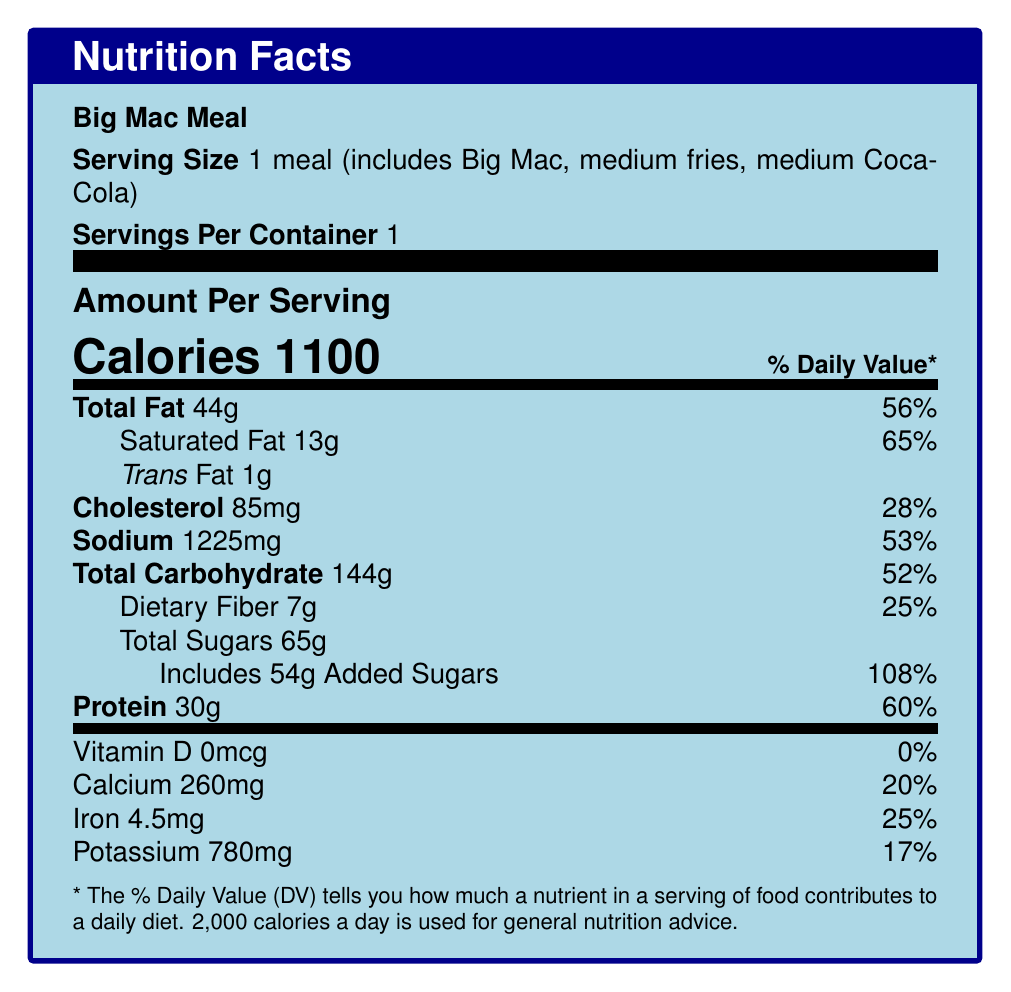what is the serving size of the Big Mac Meal? The document specifies that the serving size is 1 meal, which includes a Big Mac, medium fries, and a medium Coca-Cola.
Answer: 1 meal (includes Big Mac, medium fries, medium Coca-Cola) how many calories are in one serving of the Big Mac Meal? The document states that the meal contains 1100 calories per serving.
Answer: 1100 what is the amount of total fat in one serving? The document lists the total fat content as 44 grams per serving.
Answer: 44g how much sodium does the Big Mac Meal contain? The sodium content in one serving of the Big Mac Meal is 1225 milligrams.
Answer: 1225mg what percentage of the Daily Value for added sugars does the Big Mac Meal provide? The document indicates that the added sugars amount to 54 grams, which is 108% of the Daily Value.
Answer: 108% how much protein is in one serving of the Big Mac Meal? The meal provides 30 grams of protein per serving.
Answer: 30g what is the total carbohydrate content in one serving? A. 144g B. 100g C. 52g D. 200g The total carbohydrate content is 144 grams per serving, as stated in the document.
Answer: A. 144g what are the daily values for saturated fat and iron in the Big Mac Meal? I. 20% II. 25% III. 65% IV. 50% Saturated fat is 65% of the Daily Value, and iron is 25% of the Daily Value, as provided in the document.
Answer: III. 65% (Saturated fat), II. 25% (Iron) is there any Vitamin D in the Big Mac Meal? The document specifies that the Vitamin D content is 0 mcg, which accounts for 0% of the Daily Value.
Answer: No does the Big Mac Meal contain trans fat? The document indicates there is 1 gram of trans fat in the Big Mac Meal.
Answer: Yes what is the document mainly about? The document details the nutrition facts of a Big Mac Meal and explores various public health policies that could address the associated nutritional concerns, such as calorie labeling, sugar taxes, and nutritional education programs.
Answer: The document mainly provides the nutritional information of a Big Mac Meal, including details on calories, fats, cholesterol, sodium, carbohydrates, sugars, proteins, vitamins, and minerals. It also discusses policy implications related to nutrition labeling, sugar taxes, sodium reduction, nutritional education, and fast food zoning regulations. how can sugar taxes potentially benefit public health? The document explains that sugar taxes can reduce consumption of high-sugar items like the ones in the Big Mac Meal, thereby improving public health and providing funding for health initiatives.
Answer: By discouraging excessive consumption of sugary beverages and generating revenue for public health programs how does the Big Mac Meal support the need for sodium reduction strategies? The sodium content in the Big Mac Meal is more than half of the recommended daily intake, highlighting the urgent need for policies regulating sodium levels in food to mitigate public health risks.
Answer: The high sodium content (1225mg, 53% DV) suggests the need for national policies to reduce sodium, as excessive sodium consumption is a significant public health concern. what is the daily value percentage for cholesterol in the Big Mac Meal? The document shows that the cholesterol content is 85mg, which is 28% of the Daily Value.
Answer: 28% what could be a potential issue with implementing fast food zoning regulations? The document mentions urban planning policies to limit fast food density but doesn't provide specific challenges, such as economic impacts or community responses.
Answer: Not enough information how do political perspectives influence the policy implications discussed in the document? The explanations for calorie labeling, sugar taxes, sodium reduction, and other policies indicate that political support or opposition can significantly impact the implementation of these health measures. These perspectives can either facilitate or impede the adoption of policies aimed at improving public health.
Answer: The document outlines various political perspectives on public health policies, highlighting potential bipartisan support and opposition based on regulatory concerns, government intervention, and different ideological views on health and business. 